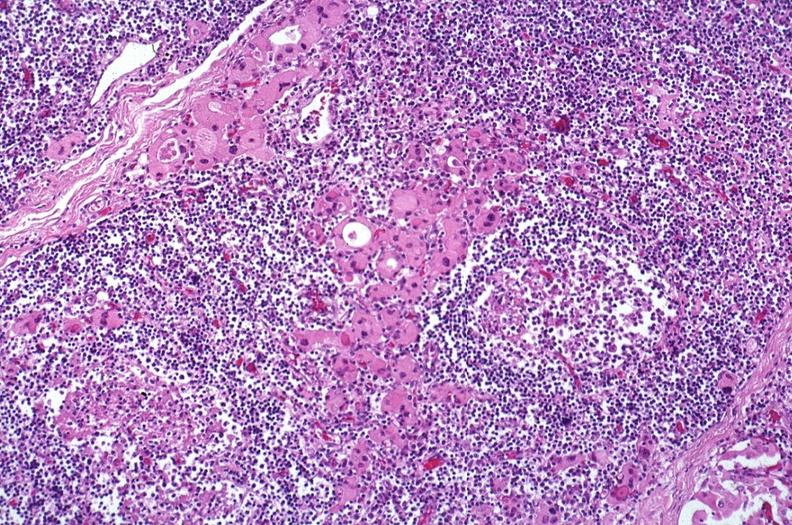s endocrine present?
Answer the question using a single word or phrase. Yes 